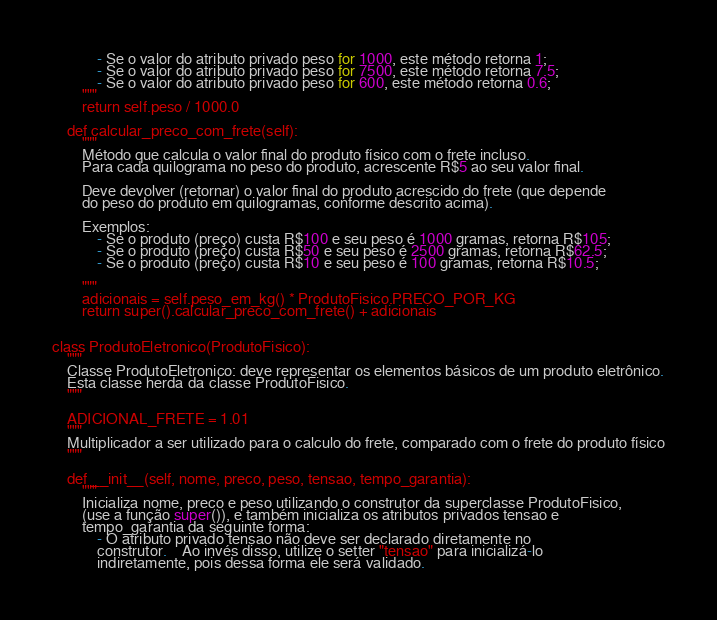<code> <loc_0><loc_0><loc_500><loc_500><_Python_>            - Se o valor do atributo privado peso for 1000, este método retorna 1;
            - Se o valor do atributo privado peso for 7500, este método retorna 7.5;
            - Se o valor do atributo privado peso for 600, este método retorna 0.6;
        """
        return self.peso / 1000.0

    def calcular_preco_com_frete(self):
        """
        Método que calcula o valor final do produto físico com o frete incluso.
        Para cada quilograma no peso do produto, acrescente R$5 ao seu valor final.

        Deve devolver (retornar) o valor final do produto acrescido do frete (que depende
        do peso do produto em quilogramas, conforme descrito acima).

        Exemplos:
            - Se o produto (preço) custa R$100 e seu peso é 1000 gramas, retorna R$105;
            - Se o produto (preço) custa R$50 e seu peso é 2500 gramas, retorna R$62.5;
            - Se o produto (preço) custa R$10 e seu peso é 100 gramas, retorna R$10.5;

        """
        adicionais = self.peso_em_kg() * ProdutoFisico.PRECO_POR_KG
        return super().calcular_preco_com_frete() + adicionais


class ProdutoEletronico(ProdutoFisico):
    """
    Classe ProdutoEletronico: deve representar os elementos básicos de um produto eletrônico.
    Esta classe herda da classe ProdutoFisico.
    """

    ADICIONAL_FRETE = 1.01
    """
    Multiplicador a ser utilizado para o calculo do frete, comparado com o frete do produto físico
    """

    def __init__(self, nome, preco, peso, tensao, tempo_garantia):
        """
        Inicializa nome, preco e peso utilizando o construtor da superclasse ProdutoFisico,
        (use a função super()), e também inicializa os atributos privados tensao e
        tempo_garantia da seguinte forma:
            - O atributo privado tensao não deve ser declarado diretamente no
            construtor.	Ao invés disso, utilize o setter "tensao" para inicializá-lo
            indiretamente, pois dessa forma ele será validado.
</code> 